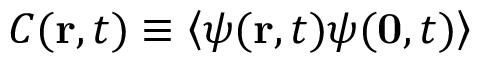Convert formula to latex. <formula><loc_0><loc_0><loc_500><loc_500>C ( { r } , t ) \equiv \left < \psi ( { r } , t ) \psi ( { 0 } , t ) \right ></formula> 